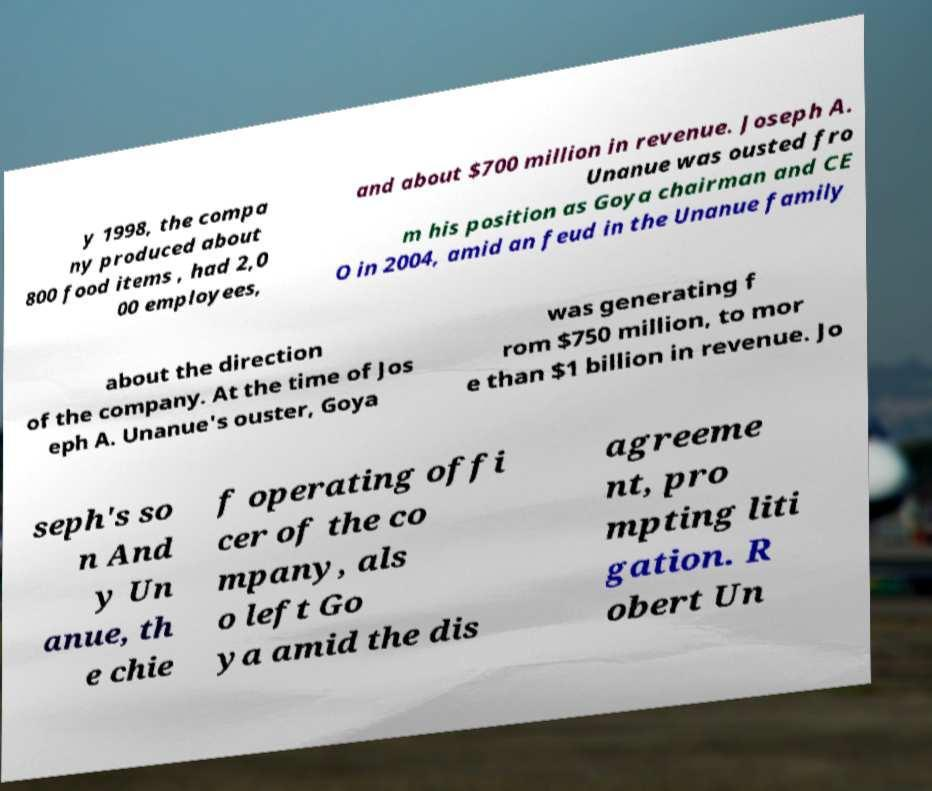There's text embedded in this image that I need extracted. Can you transcribe it verbatim? y 1998, the compa ny produced about 800 food items , had 2,0 00 employees, and about $700 million in revenue. Joseph A. Unanue was ousted fro m his position as Goya chairman and CE O in 2004, amid an feud in the Unanue family about the direction of the company. At the time of Jos eph A. Unanue's ouster, Goya was generating f rom $750 million, to mor e than $1 billion in revenue. Jo seph's so n And y Un anue, th e chie f operating offi cer of the co mpany, als o left Go ya amid the dis agreeme nt, pro mpting liti gation. R obert Un 